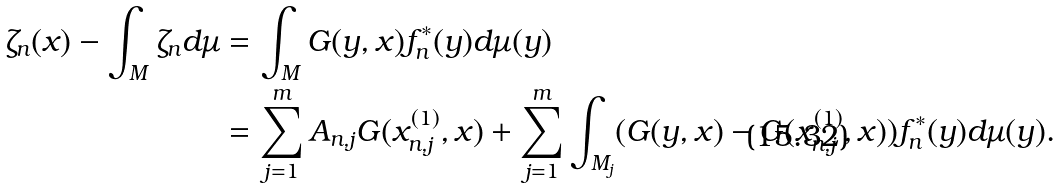Convert formula to latex. <formula><loc_0><loc_0><loc_500><loc_500>\zeta _ { n } ( x ) - \int _ { M } \zeta _ { n } d \mu & = \int _ { M } G ( y , x ) f _ { n } ^ { * } ( y ) d \mu ( y ) \\ & = \sum _ { j = 1 } ^ { m } A _ { n , j } G ( x _ { n , j } ^ { ( 1 ) } , x ) + \sum _ { j = 1 } ^ { m } \int _ { M _ { j } } ( G ( y , x ) - G ( x _ { n , j } ^ { ( 1 ) } , x ) ) f _ { n } ^ { * } ( y ) d \mu ( y ) .</formula> 